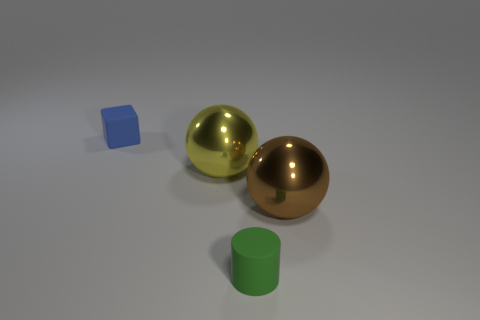Add 3 tiny cubes. How many objects exist? 7 Subtract 0 cyan cubes. How many objects are left? 4 Subtract all cylinders. How many objects are left? 3 Subtract 1 spheres. How many spheres are left? 1 Subtract all red spheres. Subtract all yellow cubes. How many spheres are left? 2 Subtract all green cylinders. How many yellow balls are left? 1 Subtract all blue rubber things. Subtract all cylinders. How many objects are left? 2 Add 4 small rubber cylinders. How many small rubber cylinders are left? 5 Add 4 big purple matte objects. How many big purple matte objects exist? 4 Subtract all yellow balls. How many balls are left? 1 